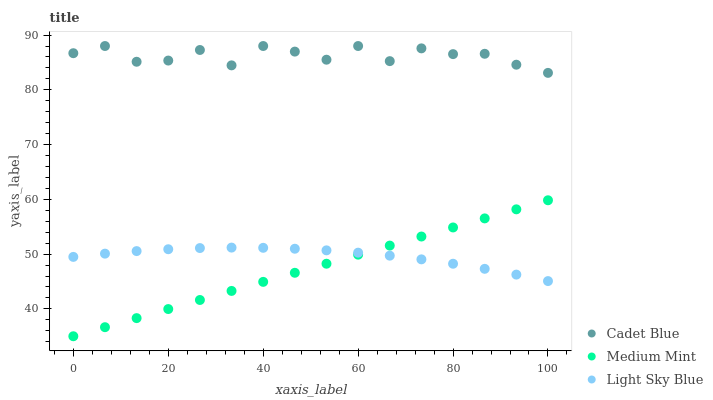Does Medium Mint have the minimum area under the curve?
Answer yes or no. Yes. Does Cadet Blue have the maximum area under the curve?
Answer yes or no. Yes. Does Light Sky Blue have the minimum area under the curve?
Answer yes or no. No. Does Light Sky Blue have the maximum area under the curve?
Answer yes or no. No. Is Medium Mint the smoothest?
Answer yes or no. Yes. Is Cadet Blue the roughest?
Answer yes or no. Yes. Is Light Sky Blue the smoothest?
Answer yes or no. No. Is Light Sky Blue the roughest?
Answer yes or no. No. Does Medium Mint have the lowest value?
Answer yes or no. Yes. Does Light Sky Blue have the lowest value?
Answer yes or no. No. Does Cadet Blue have the highest value?
Answer yes or no. Yes. Does Light Sky Blue have the highest value?
Answer yes or no. No. Is Light Sky Blue less than Cadet Blue?
Answer yes or no. Yes. Is Cadet Blue greater than Light Sky Blue?
Answer yes or no. Yes. Does Medium Mint intersect Light Sky Blue?
Answer yes or no. Yes. Is Medium Mint less than Light Sky Blue?
Answer yes or no. No. Is Medium Mint greater than Light Sky Blue?
Answer yes or no. No. Does Light Sky Blue intersect Cadet Blue?
Answer yes or no. No. 